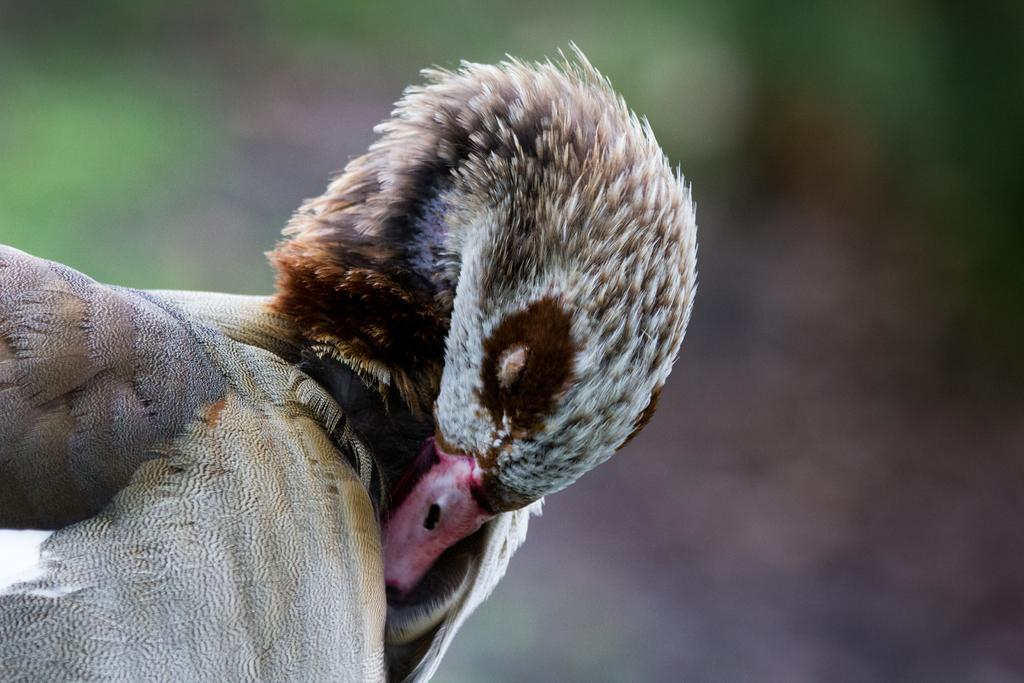What type of animal is present in the image? There is a bird in the image. Can you describe the background of the image? The background of the image is blurred. What type of beginner apparatus is being used by the writer in the image? There is no writer or apparatus present in the image; it only features a bird and a blurred background. 